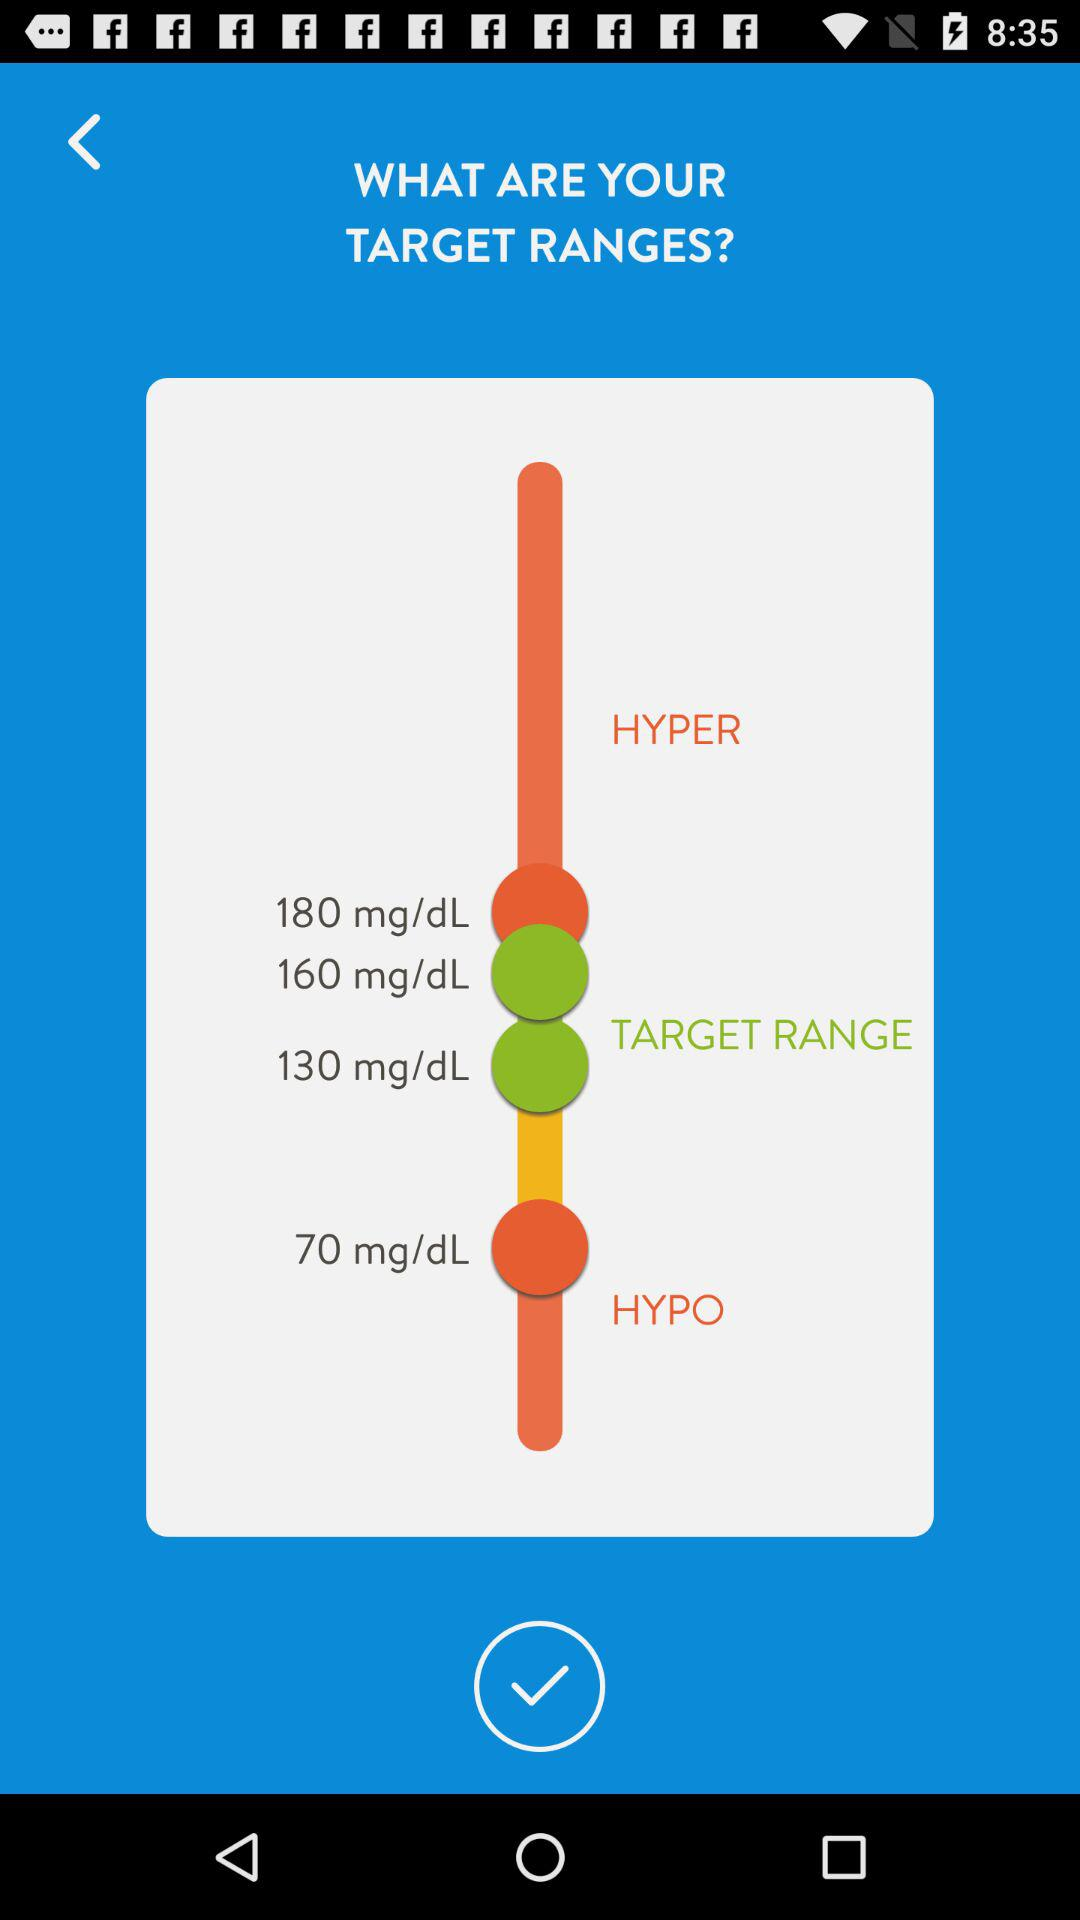What is the highest target range?
When the provided information is insufficient, respond with <no answer>. <no answer> 